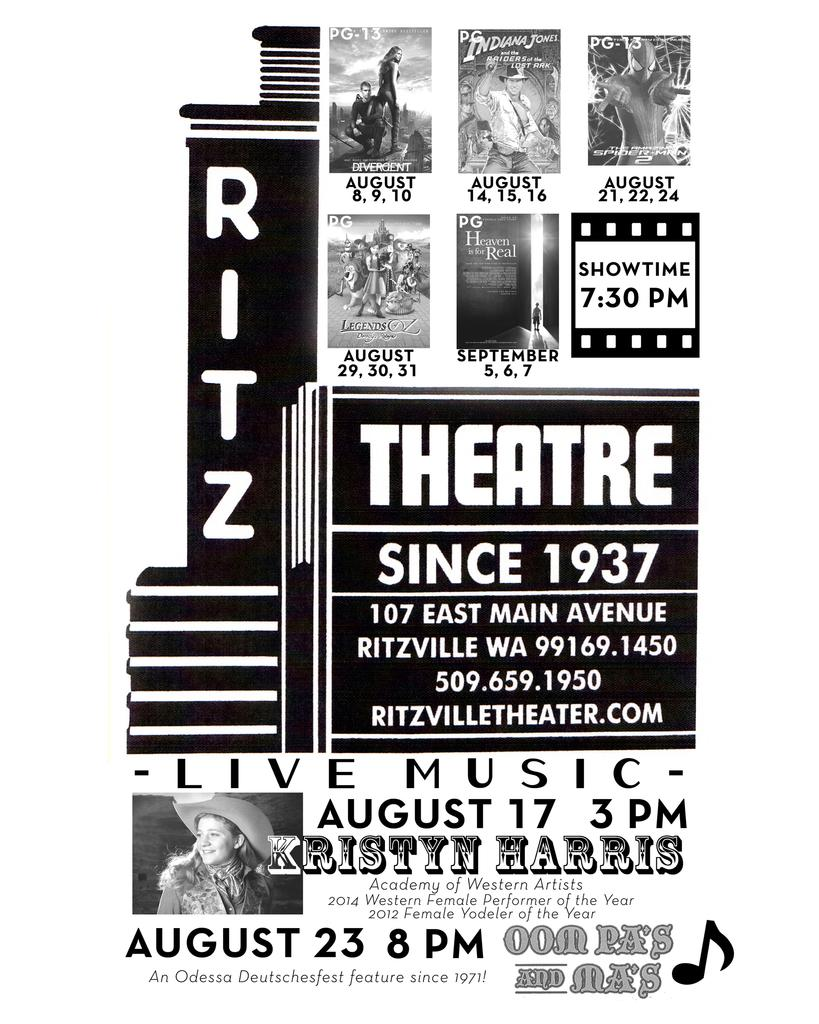<image>
Present a compact description of the photo's key features. A sign with different movies posted on it and the word theatre written in center. 